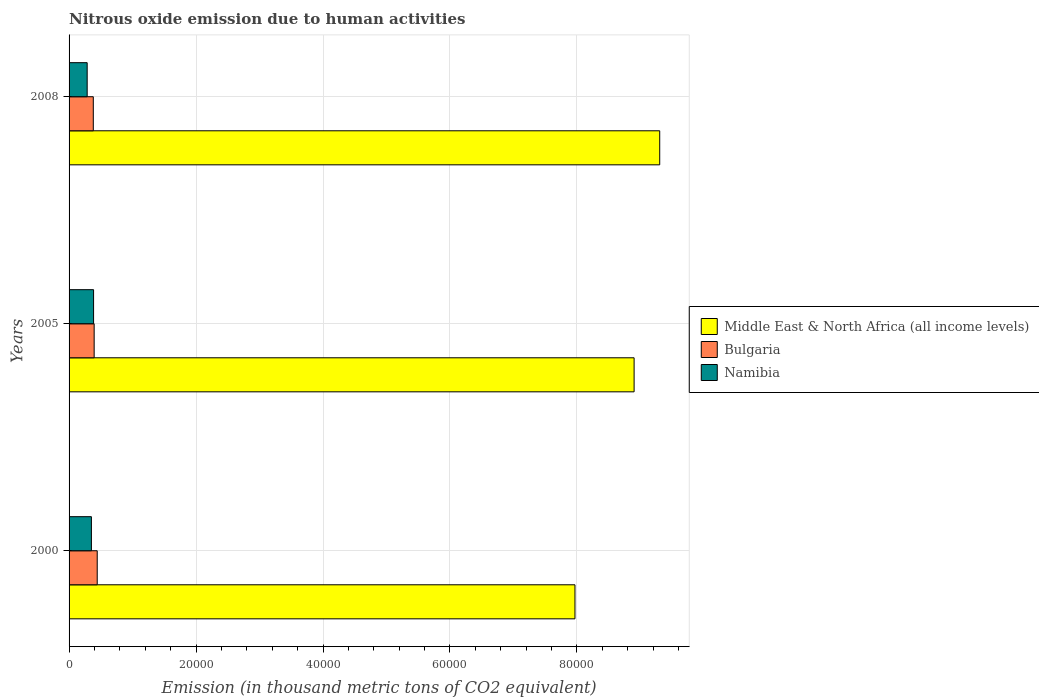How many different coloured bars are there?
Offer a terse response. 3. How many groups of bars are there?
Your answer should be compact. 3. Are the number of bars per tick equal to the number of legend labels?
Your response must be concise. Yes. Are the number of bars on each tick of the Y-axis equal?
Your answer should be very brief. Yes. How many bars are there on the 3rd tick from the top?
Give a very brief answer. 3. How many bars are there on the 2nd tick from the bottom?
Your response must be concise. 3. What is the amount of nitrous oxide emitted in Bulgaria in 2008?
Your answer should be compact. 3815.2. Across all years, what is the maximum amount of nitrous oxide emitted in Namibia?
Give a very brief answer. 3861.2. Across all years, what is the minimum amount of nitrous oxide emitted in Middle East & North Africa (all income levels)?
Your answer should be compact. 7.97e+04. In which year was the amount of nitrous oxide emitted in Middle East & North Africa (all income levels) minimum?
Your response must be concise. 2000. What is the total amount of nitrous oxide emitted in Namibia in the graph?
Offer a very short reply. 1.02e+04. What is the difference between the amount of nitrous oxide emitted in Namibia in 2000 and that in 2008?
Provide a succinct answer. 667.3. What is the difference between the amount of nitrous oxide emitted in Middle East & North Africa (all income levels) in 2005 and the amount of nitrous oxide emitted in Namibia in 2008?
Give a very brief answer. 8.62e+04. What is the average amount of nitrous oxide emitted in Middle East & North Africa (all income levels) per year?
Offer a very short reply. 8.72e+04. In the year 2000, what is the difference between the amount of nitrous oxide emitted in Bulgaria and amount of nitrous oxide emitted in Namibia?
Make the answer very short. 915.7. In how many years, is the amount of nitrous oxide emitted in Bulgaria greater than 84000 thousand metric tons?
Offer a terse response. 0. What is the ratio of the amount of nitrous oxide emitted in Bulgaria in 2000 to that in 2008?
Your answer should be compact. 1.16. What is the difference between the highest and the second highest amount of nitrous oxide emitted in Namibia?
Offer a very short reply. 342.7. What is the difference between the highest and the lowest amount of nitrous oxide emitted in Bulgaria?
Your answer should be very brief. 619. What does the 3rd bar from the top in 2000 represents?
Provide a succinct answer. Middle East & North Africa (all income levels). What does the 3rd bar from the bottom in 2008 represents?
Provide a short and direct response. Namibia. Is it the case that in every year, the sum of the amount of nitrous oxide emitted in Namibia and amount of nitrous oxide emitted in Bulgaria is greater than the amount of nitrous oxide emitted in Middle East & North Africa (all income levels)?
Make the answer very short. No. What is the difference between two consecutive major ticks on the X-axis?
Give a very brief answer. 2.00e+04. Does the graph contain any zero values?
Keep it short and to the point. No. Does the graph contain grids?
Keep it short and to the point. Yes. How many legend labels are there?
Offer a terse response. 3. What is the title of the graph?
Keep it short and to the point. Nitrous oxide emission due to human activities. What is the label or title of the X-axis?
Offer a very short reply. Emission (in thousand metric tons of CO2 equivalent). What is the Emission (in thousand metric tons of CO2 equivalent) in Middle East & North Africa (all income levels) in 2000?
Your answer should be compact. 7.97e+04. What is the Emission (in thousand metric tons of CO2 equivalent) of Bulgaria in 2000?
Keep it short and to the point. 4434.2. What is the Emission (in thousand metric tons of CO2 equivalent) of Namibia in 2000?
Provide a short and direct response. 3518.5. What is the Emission (in thousand metric tons of CO2 equivalent) of Middle East & North Africa (all income levels) in 2005?
Provide a succinct answer. 8.90e+04. What is the Emission (in thousand metric tons of CO2 equivalent) in Bulgaria in 2005?
Your response must be concise. 3951.9. What is the Emission (in thousand metric tons of CO2 equivalent) in Namibia in 2005?
Give a very brief answer. 3861.2. What is the Emission (in thousand metric tons of CO2 equivalent) of Middle East & North Africa (all income levels) in 2008?
Your response must be concise. 9.30e+04. What is the Emission (in thousand metric tons of CO2 equivalent) of Bulgaria in 2008?
Keep it short and to the point. 3815.2. What is the Emission (in thousand metric tons of CO2 equivalent) of Namibia in 2008?
Provide a succinct answer. 2851.2. Across all years, what is the maximum Emission (in thousand metric tons of CO2 equivalent) in Middle East & North Africa (all income levels)?
Provide a short and direct response. 9.30e+04. Across all years, what is the maximum Emission (in thousand metric tons of CO2 equivalent) in Bulgaria?
Offer a very short reply. 4434.2. Across all years, what is the maximum Emission (in thousand metric tons of CO2 equivalent) of Namibia?
Keep it short and to the point. 3861.2. Across all years, what is the minimum Emission (in thousand metric tons of CO2 equivalent) in Middle East & North Africa (all income levels)?
Your response must be concise. 7.97e+04. Across all years, what is the minimum Emission (in thousand metric tons of CO2 equivalent) in Bulgaria?
Your response must be concise. 3815.2. Across all years, what is the minimum Emission (in thousand metric tons of CO2 equivalent) of Namibia?
Your response must be concise. 2851.2. What is the total Emission (in thousand metric tons of CO2 equivalent) of Middle East & North Africa (all income levels) in the graph?
Keep it short and to the point. 2.62e+05. What is the total Emission (in thousand metric tons of CO2 equivalent) of Bulgaria in the graph?
Offer a very short reply. 1.22e+04. What is the total Emission (in thousand metric tons of CO2 equivalent) in Namibia in the graph?
Provide a succinct answer. 1.02e+04. What is the difference between the Emission (in thousand metric tons of CO2 equivalent) of Middle East & North Africa (all income levels) in 2000 and that in 2005?
Your response must be concise. -9317.5. What is the difference between the Emission (in thousand metric tons of CO2 equivalent) of Bulgaria in 2000 and that in 2005?
Your answer should be compact. 482.3. What is the difference between the Emission (in thousand metric tons of CO2 equivalent) in Namibia in 2000 and that in 2005?
Your answer should be very brief. -342.7. What is the difference between the Emission (in thousand metric tons of CO2 equivalent) of Middle East & North Africa (all income levels) in 2000 and that in 2008?
Keep it short and to the point. -1.34e+04. What is the difference between the Emission (in thousand metric tons of CO2 equivalent) in Bulgaria in 2000 and that in 2008?
Your response must be concise. 619. What is the difference between the Emission (in thousand metric tons of CO2 equivalent) in Namibia in 2000 and that in 2008?
Keep it short and to the point. 667.3. What is the difference between the Emission (in thousand metric tons of CO2 equivalent) of Middle East & North Africa (all income levels) in 2005 and that in 2008?
Make the answer very short. -4035.3. What is the difference between the Emission (in thousand metric tons of CO2 equivalent) of Bulgaria in 2005 and that in 2008?
Make the answer very short. 136.7. What is the difference between the Emission (in thousand metric tons of CO2 equivalent) of Namibia in 2005 and that in 2008?
Your answer should be compact. 1010. What is the difference between the Emission (in thousand metric tons of CO2 equivalent) in Middle East & North Africa (all income levels) in 2000 and the Emission (in thousand metric tons of CO2 equivalent) in Bulgaria in 2005?
Offer a terse response. 7.57e+04. What is the difference between the Emission (in thousand metric tons of CO2 equivalent) of Middle East & North Africa (all income levels) in 2000 and the Emission (in thousand metric tons of CO2 equivalent) of Namibia in 2005?
Your answer should be compact. 7.58e+04. What is the difference between the Emission (in thousand metric tons of CO2 equivalent) of Bulgaria in 2000 and the Emission (in thousand metric tons of CO2 equivalent) of Namibia in 2005?
Your answer should be very brief. 573. What is the difference between the Emission (in thousand metric tons of CO2 equivalent) of Middle East & North Africa (all income levels) in 2000 and the Emission (in thousand metric tons of CO2 equivalent) of Bulgaria in 2008?
Your response must be concise. 7.59e+04. What is the difference between the Emission (in thousand metric tons of CO2 equivalent) in Middle East & North Africa (all income levels) in 2000 and the Emission (in thousand metric tons of CO2 equivalent) in Namibia in 2008?
Provide a succinct answer. 7.68e+04. What is the difference between the Emission (in thousand metric tons of CO2 equivalent) of Bulgaria in 2000 and the Emission (in thousand metric tons of CO2 equivalent) of Namibia in 2008?
Give a very brief answer. 1583. What is the difference between the Emission (in thousand metric tons of CO2 equivalent) of Middle East & North Africa (all income levels) in 2005 and the Emission (in thousand metric tons of CO2 equivalent) of Bulgaria in 2008?
Make the answer very short. 8.52e+04. What is the difference between the Emission (in thousand metric tons of CO2 equivalent) in Middle East & North Africa (all income levels) in 2005 and the Emission (in thousand metric tons of CO2 equivalent) in Namibia in 2008?
Provide a succinct answer. 8.62e+04. What is the difference between the Emission (in thousand metric tons of CO2 equivalent) in Bulgaria in 2005 and the Emission (in thousand metric tons of CO2 equivalent) in Namibia in 2008?
Ensure brevity in your answer.  1100.7. What is the average Emission (in thousand metric tons of CO2 equivalent) in Middle East & North Africa (all income levels) per year?
Offer a terse response. 8.72e+04. What is the average Emission (in thousand metric tons of CO2 equivalent) in Bulgaria per year?
Give a very brief answer. 4067.1. What is the average Emission (in thousand metric tons of CO2 equivalent) in Namibia per year?
Ensure brevity in your answer.  3410.3. In the year 2000, what is the difference between the Emission (in thousand metric tons of CO2 equivalent) of Middle East & North Africa (all income levels) and Emission (in thousand metric tons of CO2 equivalent) of Bulgaria?
Your answer should be compact. 7.53e+04. In the year 2000, what is the difference between the Emission (in thousand metric tons of CO2 equivalent) of Middle East & North Africa (all income levels) and Emission (in thousand metric tons of CO2 equivalent) of Namibia?
Ensure brevity in your answer.  7.62e+04. In the year 2000, what is the difference between the Emission (in thousand metric tons of CO2 equivalent) of Bulgaria and Emission (in thousand metric tons of CO2 equivalent) of Namibia?
Keep it short and to the point. 915.7. In the year 2005, what is the difference between the Emission (in thousand metric tons of CO2 equivalent) in Middle East & North Africa (all income levels) and Emission (in thousand metric tons of CO2 equivalent) in Bulgaria?
Offer a very short reply. 8.51e+04. In the year 2005, what is the difference between the Emission (in thousand metric tons of CO2 equivalent) in Middle East & North Africa (all income levels) and Emission (in thousand metric tons of CO2 equivalent) in Namibia?
Provide a succinct answer. 8.51e+04. In the year 2005, what is the difference between the Emission (in thousand metric tons of CO2 equivalent) of Bulgaria and Emission (in thousand metric tons of CO2 equivalent) of Namibia?
Your answer should be compact. 90.7. In the year 2008, what is the difference between the Emission (in thousand metric tons of CO2 equivalent) in Middle East & North Africa (all income levels) and Emission (in thousand metric tons of CO2 equivalent) in Bulgaria?
Provide a succinct answer. 8.92e+04. In the year 2008, what is the difference between the Emission (in thousand metric tons of CO2 equivalent) of Middle East & North Africa (all income levels) and Emission (in thousand metric tons of CO2 equivalent) of Namibia?
Your answer should be very brief. 9.02e+04. In the year 2008, what is the difference between the Emission (in thousand metric tons of CO2 equivalent) of Bulgaria and Emission (in thousand metric tons of CO2 equivalent) of Namibia?
Give a very brief answer. 964. What is the ratio of the Emission (in thousand metric tons of CO2 equivalent) in Middle East & North Africa (all income levels) in 2000 to that in 2005?
Give a very brief answer. 0.9. What is the ratio of the Emission (in thousand metric tons of CO2 equivalent) of Bulgaria in 2000 to that in 2005?
Your response must be concise. 1.12. What is the ratio of the Emission (in thousand metric tons of CO2 equivalent) in Namibia in 2000 to that in 2005?
Provide a short and direct response. 0.91. What is the ratio of the Emission (in thousand metric tons of CO2 equivalent) of Middle East & North Africa (all income levels) in 2000 to that in 2008?
Provide a succinct answer. 0.86. What is the ratio of the Emission (in thousand metric tons of CO2 equivalent) in Bulgaria in 2000 to that in 2008?
Offer a very short reply. 1.16. What is the ratio of the Emission (in thousand metric tons of CO2 equivalent) of Namibia in 2000 to that in 2008?
Make the answer very short. 1.23. What is the ratio of the Emission (in thousand metric tons of CO2 equivalent) of Middle East & North Africa (all income levels) in 2005 to that in 2008?
Give a very brief answer. 0.96. What is the ratio of the Emission (in thousand metric tons of CO2 equivalent) in Bulgaria in 2005 to that in 2008?
Ensure brevity in your answer.  1.04. What is the ratio of the Emission (in thousand metric tons of CO2 equivalent) in Namibia in 2005 to that in 2008?
Make the answer very short. 1.35. What is the difference between the highest and the second highest Emission (in thousand metric tons of CO2 equivalent) of Middle East & North Africa (all income levels)?
Provide a short and direct response. 4035.3. What is the difference between the highest and the second highest Emission (in thousand metric tons of CO2 equivalent) of Bulgaria?
Your answer should be compact. 482.3. What is the difference between the highest and the second highest Emission (in thousand metric tons of CO2 equivalent) of Namibia?
Your answer should be very brief. 342.7. What is the difference between the highest and the lowest Emission (in thousand metric tons of CO2 equivalent) of Middle East & North Africa (all income levels)?
Offer a very short reply. 1.34e+04. What is the difference between the highest and the lowest Emission (in thousand metric tons of CO2 equivalent) in Bulgaria?
Ensure brevity in your answer.  619. What is the difference between the highest and the lowest Emission (in thousand metric tons of CO2 equivalent) of Namibia?
Offer a terse response. 1010. 